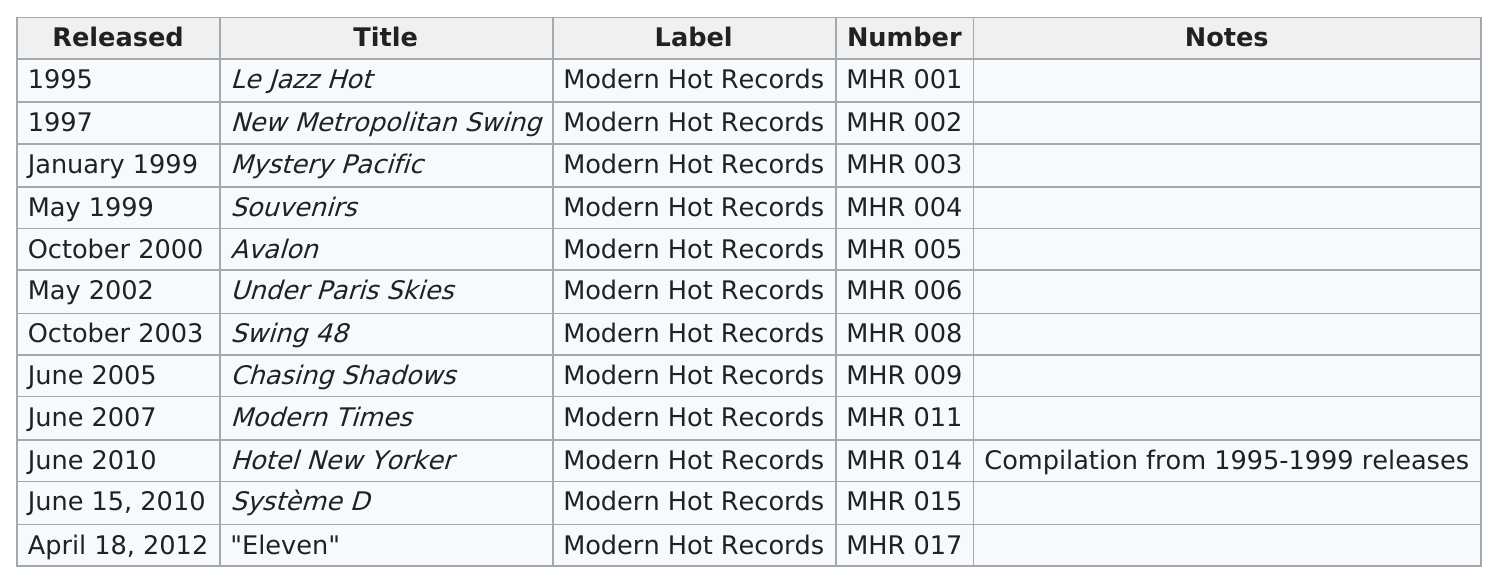Identify some key points in this picture. There is one compilation album. After 2009, the artist Pearl Django released a total of three albums. The information given is that Mystic Pacific and souvenirs are from the year 1999. The time interval between the release of the first and most recent albums is 17 years. The album 'Hotel New Yorker' contains no original music. 